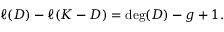Convert formula to latex. <formula><loc_0><loc_0><loc_500><loc_500>\ell ( D ) - \ell ( K - D ) = \deg ( D ) - g + 1 .</formula> 